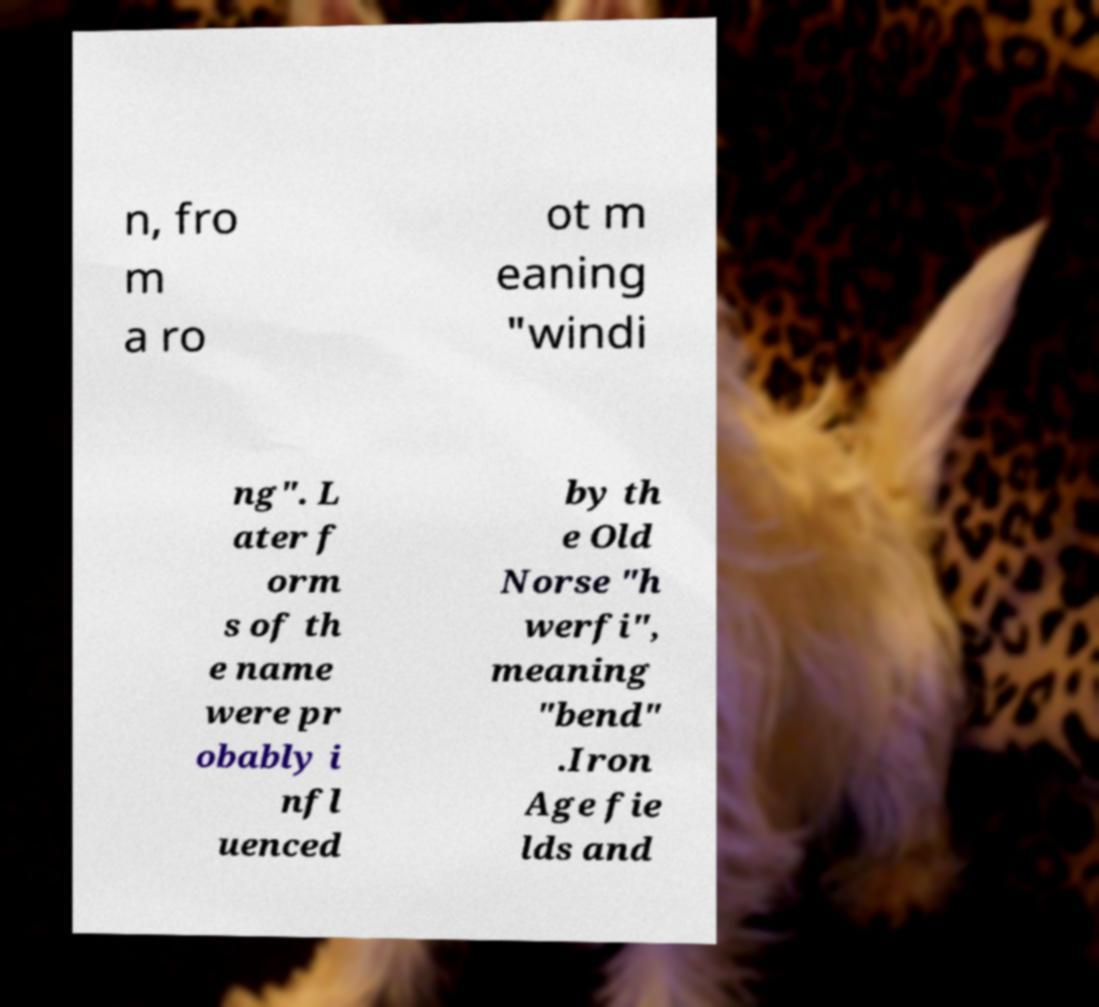There's text embedded in this image that I need extracted. Can you transcribe it verbatim? n, fro m a ro ot m eaning "windi ng". L ater f orm s of th e name were pr obably i nfl uenced by th e Old Norse "h werfi", meaning "bend" .Iron Age fie lds and 